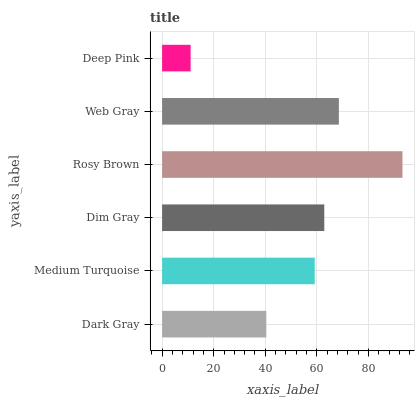Is Deep Pink the minimum?
Answer yes or no. Yes. Is Rosy Brown the maximum?
Answer yes or no. Yes. Is Medium Turquoise the minimum?
Answer yes or no. No. Is Medium Turquoise the maximum?
Answer yes or no. No. Is Medium Turquoise greater than Dark Gray?
Answer yes or no. Yes. Is Dark Gray less than Medium Turquoise?
Answer yes or no. Yes. Is Dark Gray greater than Medium Turquoise?
Answer yes or no. No. Is Medium Turquoise less than Dark Gray?
Answer yes or no. No. Is Dim Gray the high median?
Answer yes or no. Yes. Is Medium Turquoise the low median?
Answer yes or no. Yes. Is Deep Pink the high median?
Answer yes or no. No. Is Dim Gray the low median?
Answer yes or no. No. 